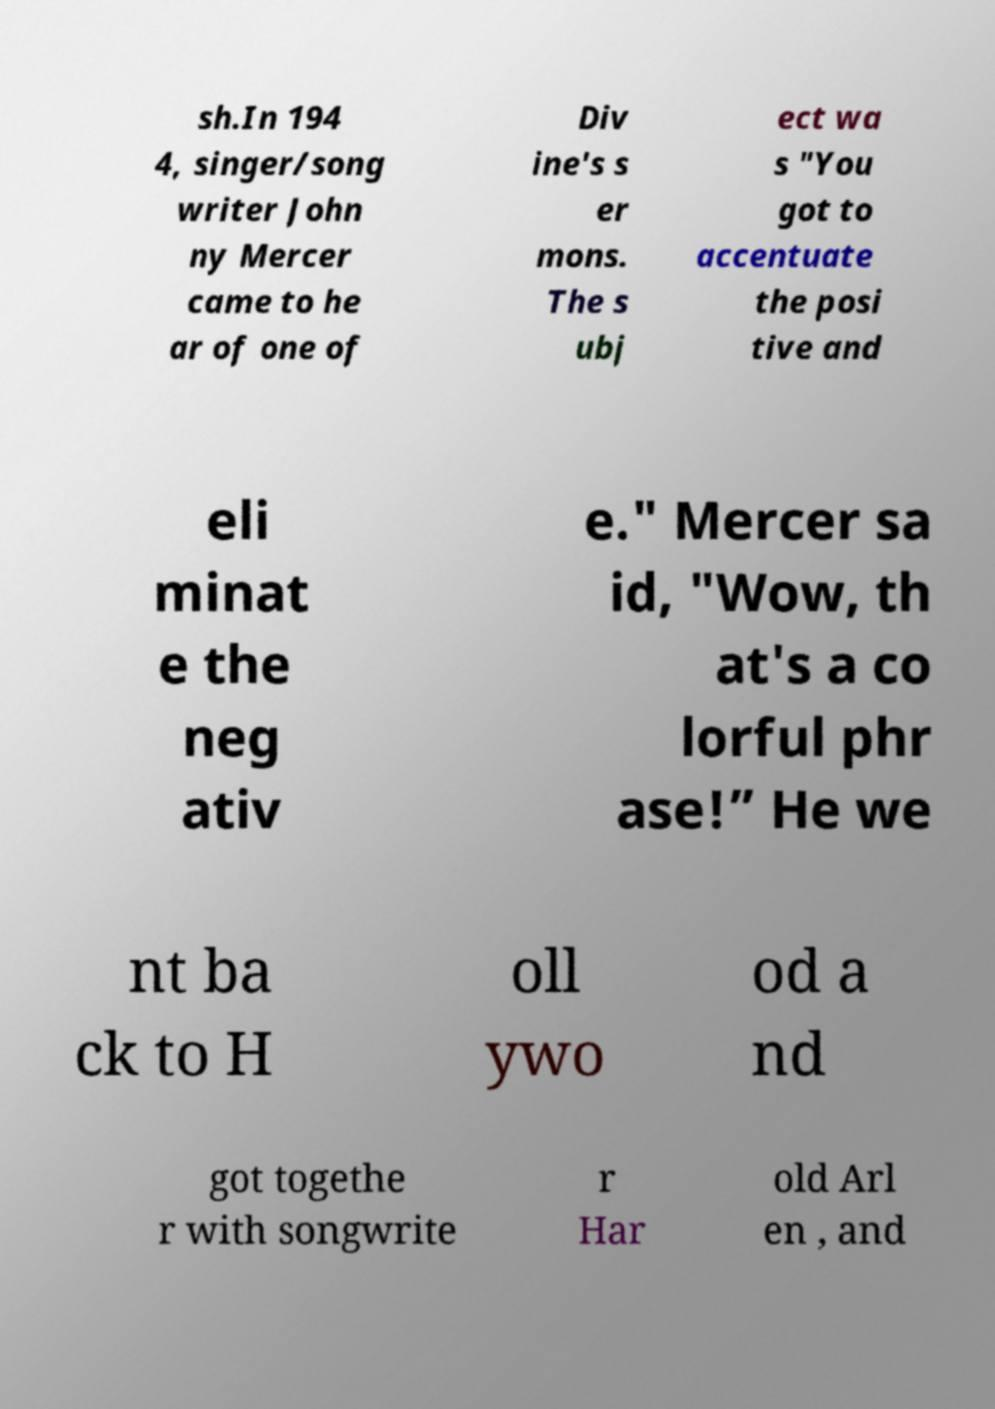There's text embedded in this image that I need extracted. Can you transcribe it verbatim? sh.In 194 4, singer/song writer John ny Mercer came to he ar of one of Div ine's s er mons. The s ubj ect wa s "You got to accentuate the posi tive and eli minat e the neg ativ e." Mercer sa id, "Wow, th at's a co lorful phr ase!” He we nt ba ck to H oll ywo od a nd got togethe r with songwrite r Har old Arl en , and 